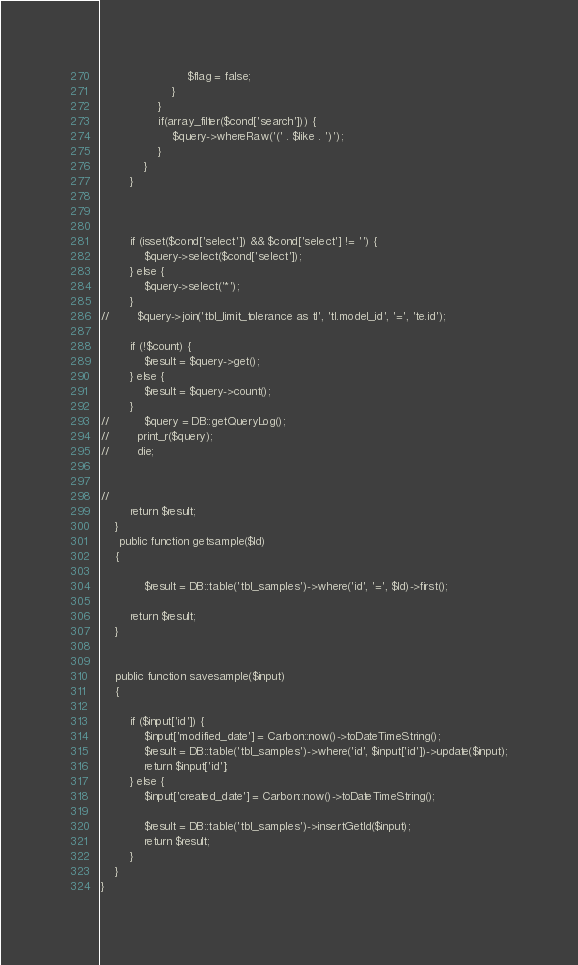Convert code to text. <code><loc_0><loc_0><loc_500><loc_500><_PHP_>                        $flag = false;
                    }
                }
                if(array_filter($cond['search'])) {
                    $query->whereRaw('(' . $like . ')');
                }
            }
        }



        if (isset($cond['select']) && $cond['select'] != '') {
            $query->select($cond['select']);
        } else {
            $query->select('*');
        }
//        $query->join('tbl_limit_tolerance as tl', 'tl.model_id', '=', 'te.id');

        if (!$count) {
            $result = $query->get();
        } else {
            $result = $query->count();
        }
//          $query = DB::getQueryLog();
//        print_r($query);
//        die;


//
        return $result;
    }
     public function getsample($Id)
    {
       
            $result = DB::table('tbl_samples')->where('id', '=', $Id)->first();
       
        return $result;
    }
    
     
    public function savesample($input)
    {

        if ($input['id']) {
            $input['modified_date'] = Carbon::now()->toDateTimeString();
            $result = DB::table('tbl_samples')->where('id', $input['id'])->update($input);
            return $input['id'];
        } else {
            $input['created_date'] = Carbon::now()->toDateTimeString();

            $result = DB::table('tbl_samples')->insertGetId($input);
            return $result;
        }
    }
}</code> 